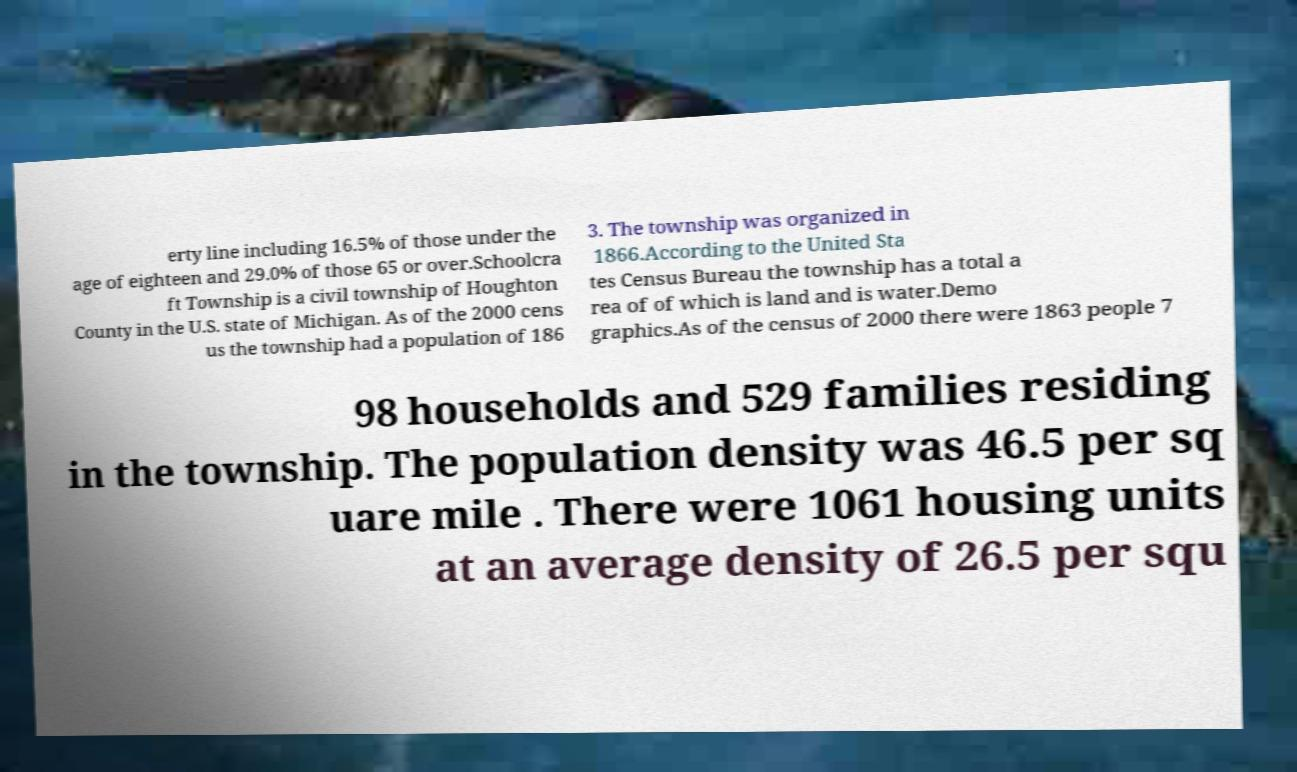Could you extract and type out the text from this image? erty line including 16.5% of those under the age of eighteen and 29.0% of those 65 or over.Schoolcra ft Township is a civil township of Houghton County in the U.S. state of Michigan. As of the 2000 cens us the township had a population of 186 3. The township was organized in 1866.According to the United Sta tes Census Bureau the township has a total a rea of of which is land and is water.Demo graphics.As of the census of 2000 there were 1863 people 7 98 households and 529 families residing in the township. The population density was 46.5 per sq uare mile . There were 1061 housing units at an average density of 26.5 per squ 